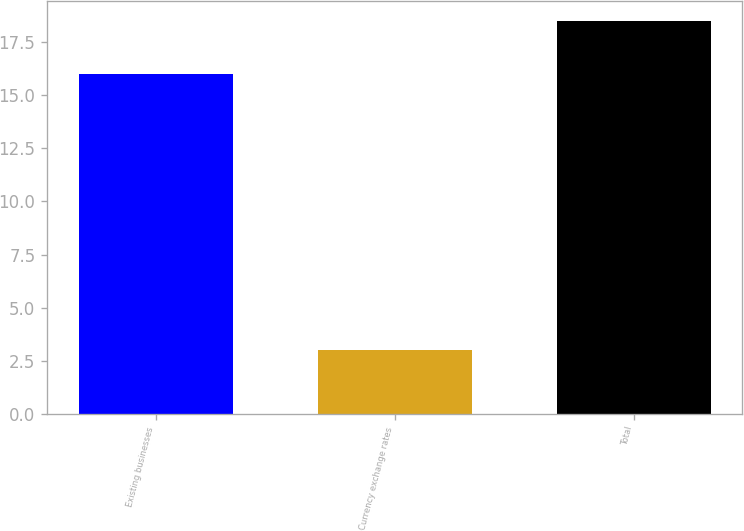Convert chart to OTSL. <chart><loc_0><loc_0><loc_500><loc_500><bar_chart><fcel>Existing businesses<fcel>Currency exchange rates<fcel>Total<nl><fcel>16<fcel>3<fcel>18.5<nl></chart> 